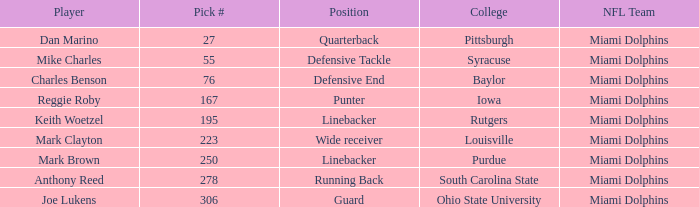Which College has Player Mark Brown and a Pick # greater than 195? Purdue. 